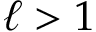<formula> <loc_0><loc_0><loc_500><loc_500>\ell > 1</formula> 